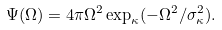Convert formula to latex. <formula><loc_0><loc_0><loc_500><loc_500>\Psi ( \Omega ) = 4 \pi \Omega ^ { 2 } \exp _ { \kappa } ( - \Omega ^ { 2 } / \sigma _ { \kappa } ^ { 2 } ) .</formula> 